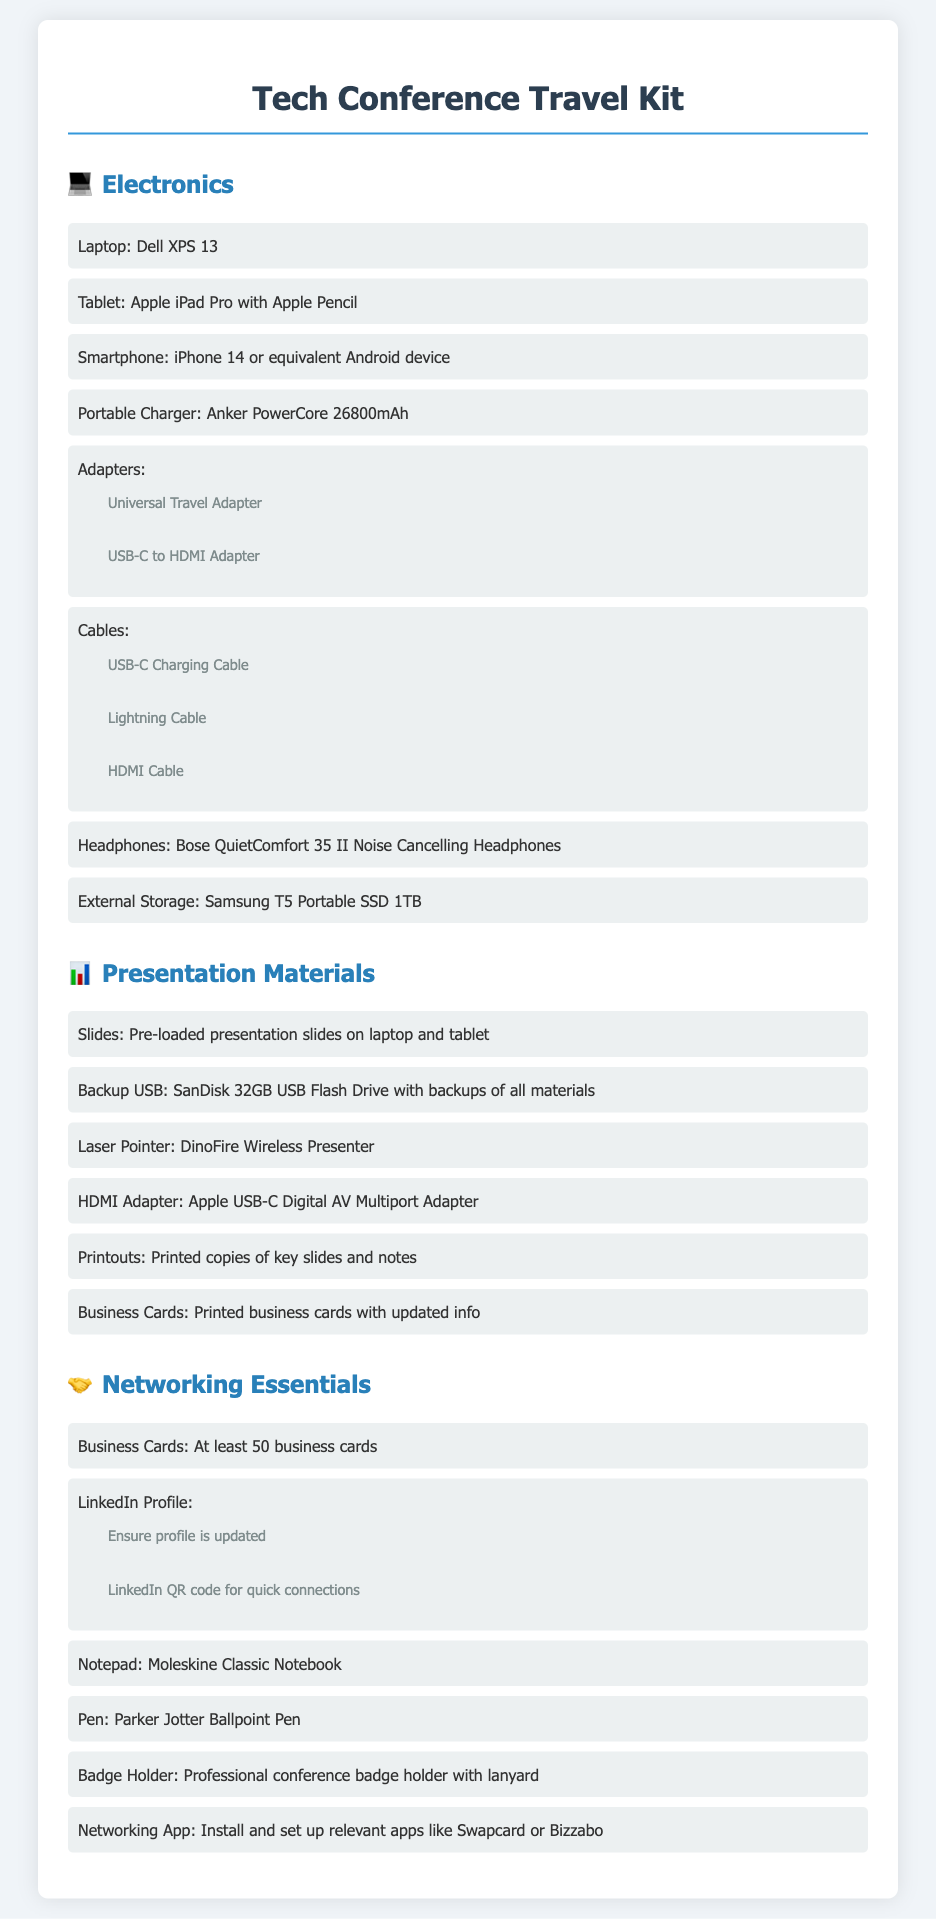What laptop is recommended for the conference? The document lists "Dell XPS 13" as the recommended laptop for the conference.
Answer: Dell XPS 13 What are the recommended headphones? The document specifies "Bose QuietComfort 35 II Noise Cancelling Headphones" as the recommended headphones.
Answer: Bose QuietComfort 35 II Noise Cancelling Headphones How many business cards should you bring? The document advises to bring "at least 50 business cards" for networking purposes.
Answer: at least 50 business cards Which portable storage device is suggested? The document recommends "Samsung T5 Portable SSD 1TB" for external storage.
Answer: Samsung T5 Portable SSD 1TB How many adapters are listed under electronics? The section lists two types of adapters: Universal Travel Adapter and USB-C to HDMI Adapter, totaling two adapters.
Answer: 2 What is included in the presentation materials section? The document includes multiple items such as pre-loaded slides, backup USB, and printed copies of key slides.
Answer: pre-loaded slides, backup USB, printed copies of key slides What is one of the networking apps recommended? The document suggests installing "Swapcard" or another similar app for networking.
Answer: Swapcard What type of notebook is recommended for taking notes? The document recommends a "Moleskine Classic Notebook" for note-taking.
Answer: Moleskine Classic Notebook 